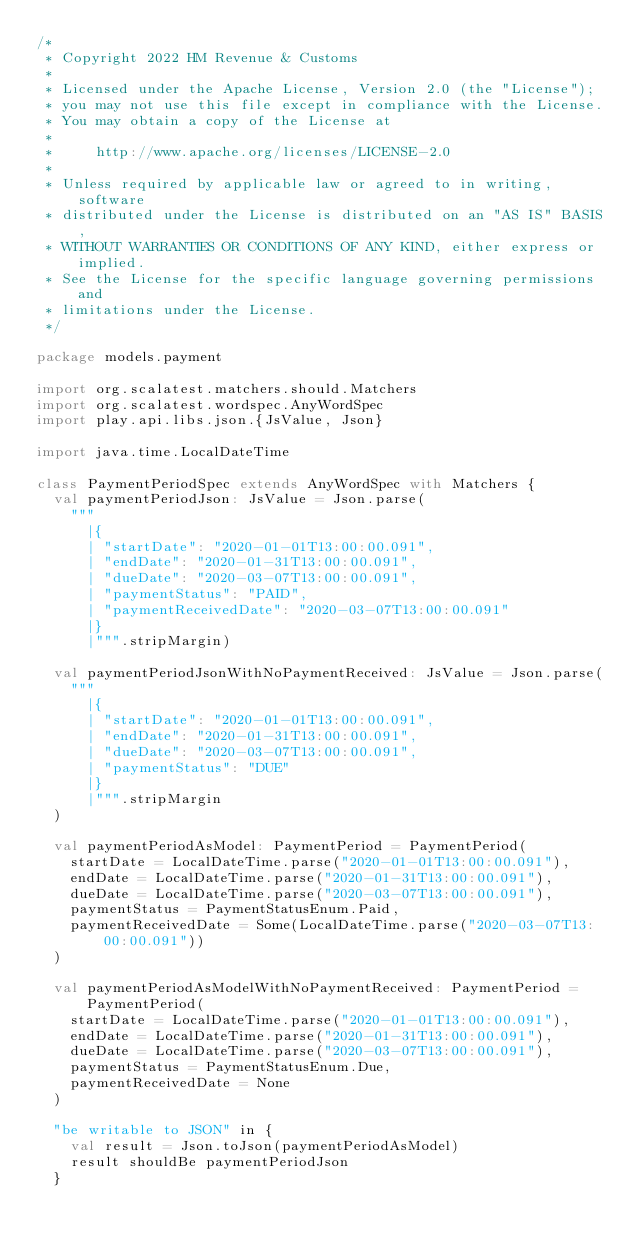Convert code to text. <code><loc_0><loc_0><loc_500><loc_500><_Scala_>/*
 * Copyright 2022 HM Revenue & Customs
 *
 * Licensed under the Apache License, Version 2.0 (the "License");
 * you may not use this file except in compliance with the License.
 * You may obtain a copy of the License at
 *
 *     http://www.apache.org/licenses/LICENSE-2.0
 *
 * Unless required by applicable law or agreed to in writing, software
 * distributed under the License is distributed on an "AS IS" BASIS,
 * WITHOUT WARRANTIES OR CONDITIONS OF ANY KIND, either express or implied.
 * See the License for the specific language governing permissions and
 * limitations under the License.
 */

package models.payment

import org.scalatest.matchers.should.Matchers
import org.scalatest.wordspec.AnyWordSpec
import play.api.libs.json.{JsValue, Json}

import java.time.LocalDateTime

class PaymentPeriodSpec extends AnyWordSpec with Matchers {
  val paymentPeriodJson: JsValue = Json.parse(
    """
      |{
      | "startDate": "2020-01-01T13:00:00.091",
      | "endDate": "2020-01-31T13:00:00.091",
      | "dueDate": "2020-03-07T13:00:00.091",
      | "paymentStatus": "PAID",
      | "paymentReceivedDate": "2020-03-07T13:00:00.091"
      |}
      |""".stripMargin)

  val paymentPeriodJsonWithNoPaymentReceived: JsValue = Json.parse(
    """
      |{
      | "startDate": "2020-01-01T13:00:00.091",
      | "endDate": "2020-01-31T13:00:00.091",
      | "dueDate": "2020-03-07T13:00:00.091",
      | "paymentStatus": "DUE"
      |}
      |""".stripMargin
  )

  val paymentPeriodAsModel: PaymentPeriod = PaymentPeriod(
    startDate = LocalDateTime.parse("2020-01-01T13:00:00.091"),
    endDate = LocalDateTime.parse("2020-01-31T13:00:00.091"),
    dueDate = LocalDateTime.parse("2020-03-07T13:00:00.091"),
    paymentStatus = PaymentStatusEnum.Paid,
    paymentReceivedDate = Some(LocalDateTime.parse("2020-03-07T13:00:00.091"))
  )

  val paymentPeriodAsModelWithNoPaymentReceived: PaymentPeriod = PaymentPeriod(
    startDate = LocalDateTime.parse("2020-01-01T13:00:00.091"),
    endDate = LocalDateTime.parse("2020-01-31T13:00:00.091"),
    dueDate = LocalDateTime.parse("2020-03-07T13:00:00.091"),
    paymentStatus = PaymentStatusEnum.Due,
    paymentReceivedDate = None
  )

  "be writable to JSON" in {
    val result = Json.toJson(paymentPeriodAsModel)
    result shouldBe paymentPeriodJson
  }
</code> 